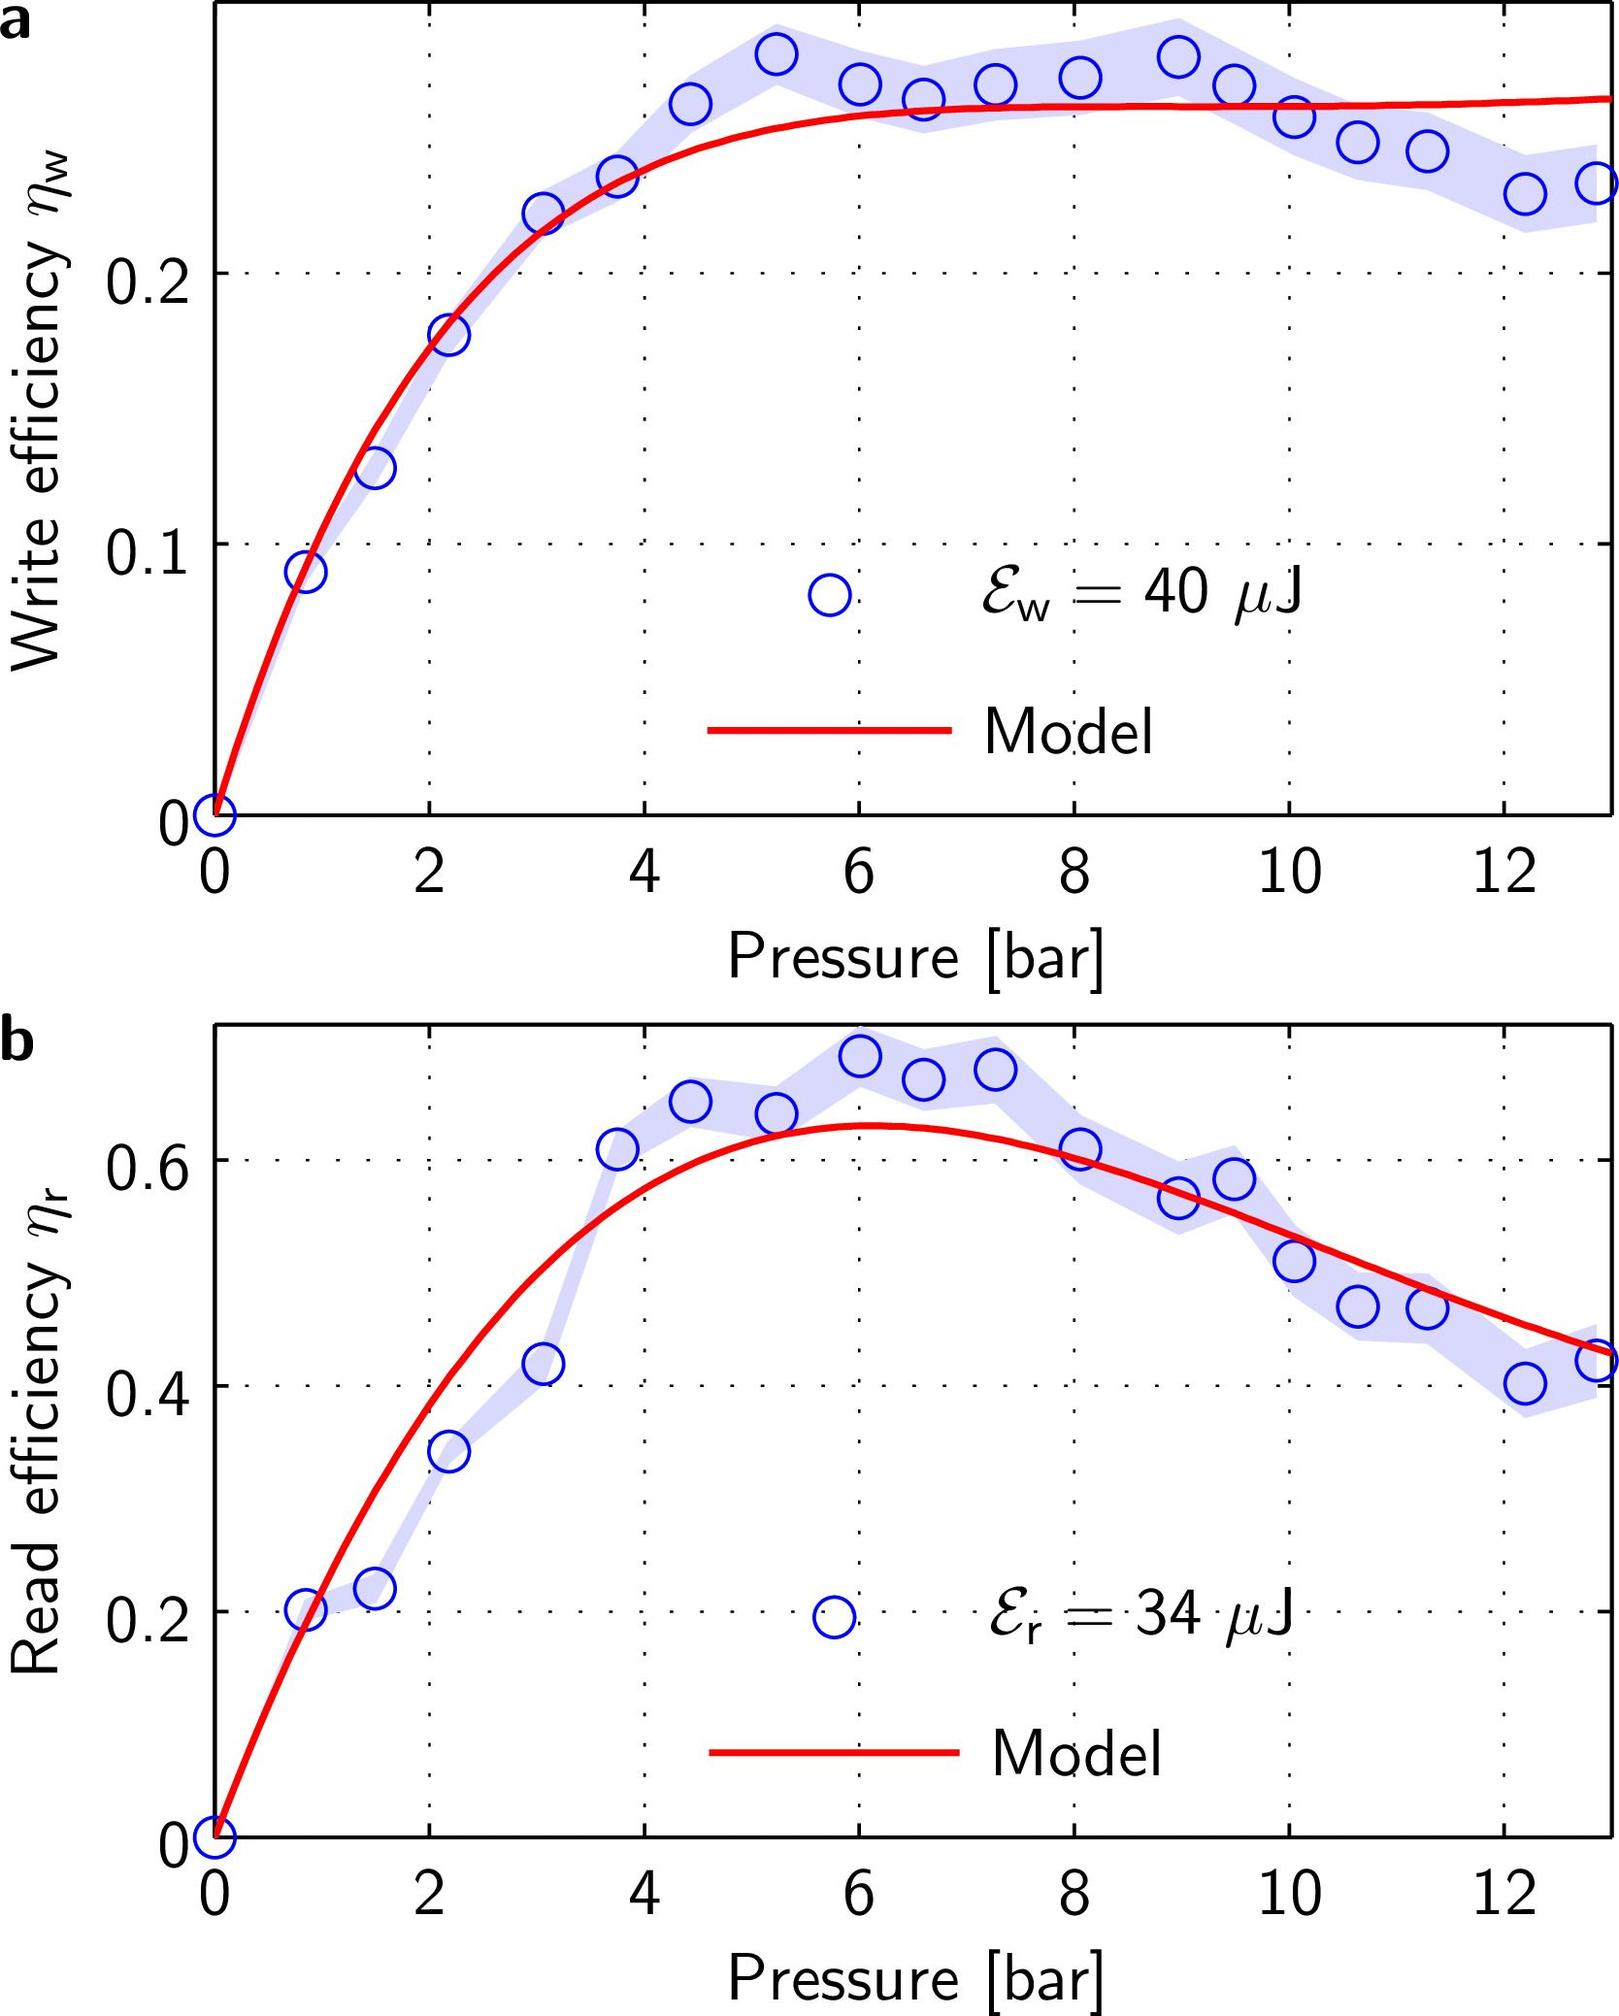Why does the write efficiency curve have a different shape compared to the read efficiency curve in figure b? The difference in the shape of the efficiency curves for writing and reading in the figures can be attributed to the different energies used and perhaps the inherent process mechanisms. While the write efficiency uses 40 \\(\muJ\\), the read efficiency uses only 34 \\(\muJ\\). This difference implies that the process dynamics, such as the amount of energy required to align or re-align the particles during writing versus reading, vary, resulting in different optimal pressure ranges and curve shapes. 